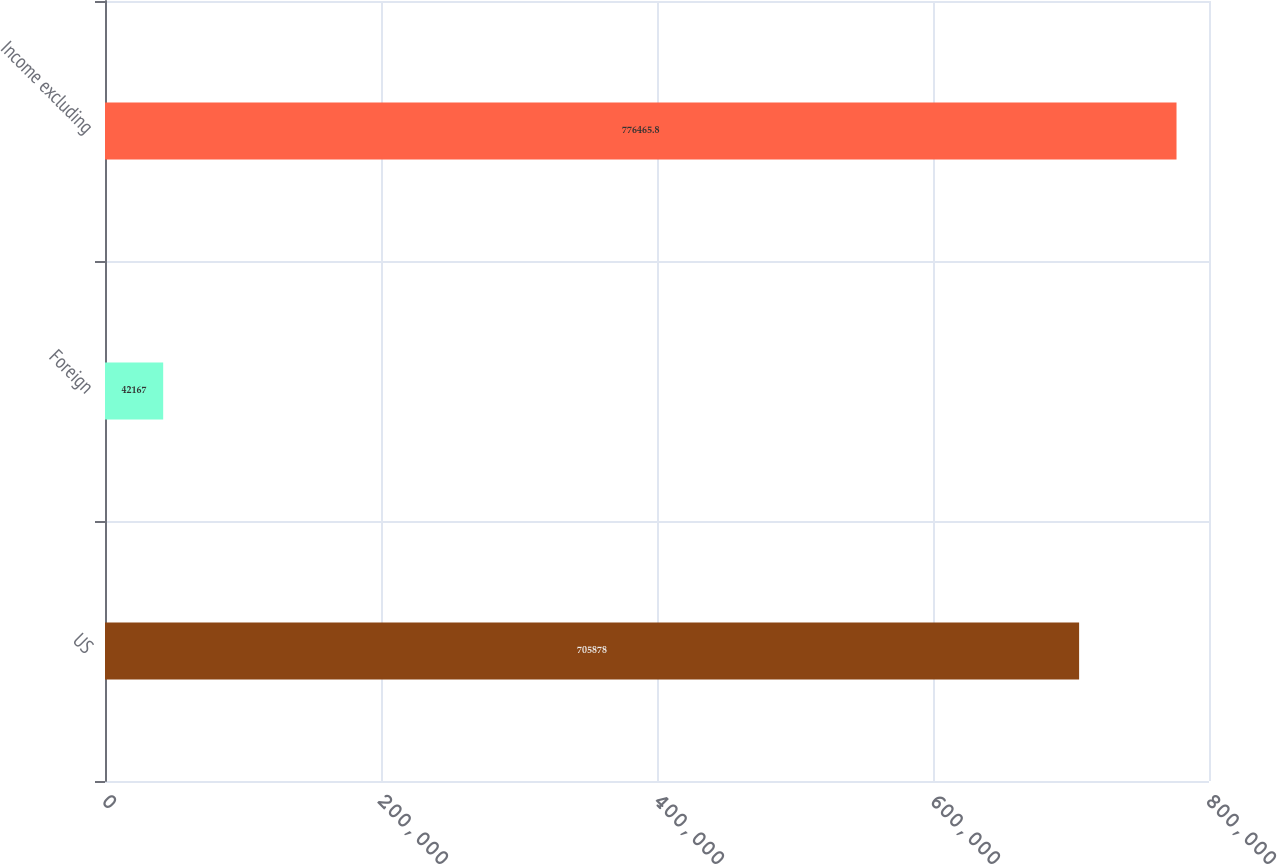Convert chart to OTSL. <chart><loc_0><loc_0><loc_500><loc_500><bar_chart><fcel>US<fcel>Foreign<fcel>Income excluding<nl><fcel>705878<fcel>42167<fcel>776466<nl></chart> 